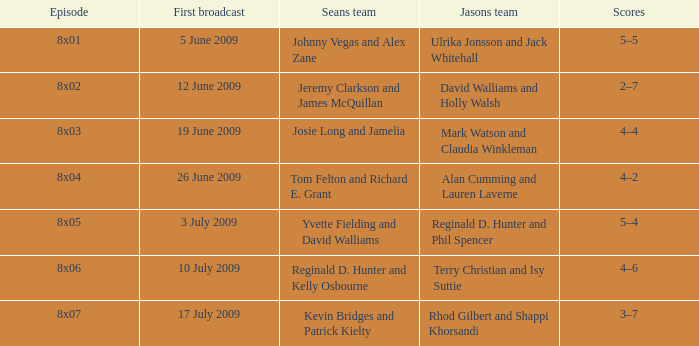In how many episodes did Sean's team include Jeremy Clarkson and James McQuillan? 1.0. 